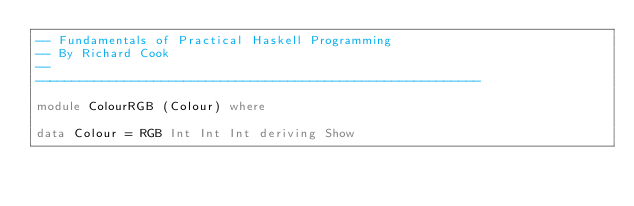Convert code to text. <code><loc_0><loc_0><loc_500><loc_500><_Haskell_>-- Fundamentals of Practical Haskell Programming
-- By Richard Cook
--
------------------------------------------------------------

module ColourRGB (Colour) where

data Colour = RGB Int Int Int deriving Show
</code> 